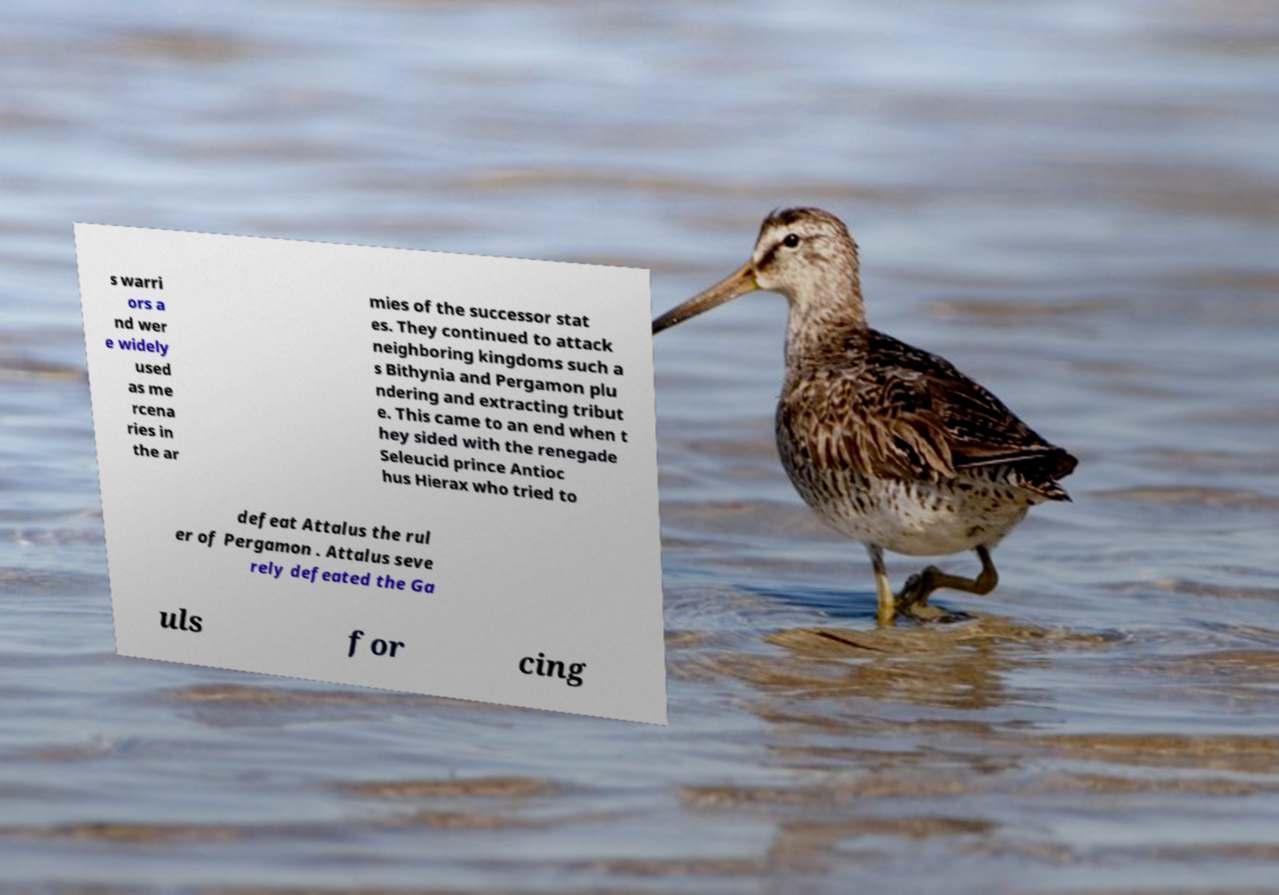What messages or text are displayed in this image? I need them in a readable, typed format. s warri ors a nd wer e widely used as me rcena ries in the ar mies of the successor stat es. They continued to attack neighboring kingdoms such a s Bithynia and Pergamon plu ndering and extracting tribut e. This came to an end when t hey sided with the renegade Seleucid prince Antioc hus Hierax who tried to defeat Attalus the rul er of Pergamon . Attalus seve rely defeated the Ga uls for cing 